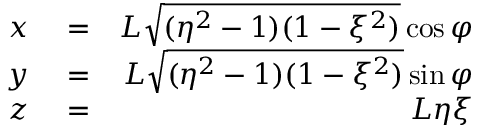Convert formula to latex. <formula><loc_0><loc_0><loc_500><loc_500>\begin{array} { r l r } { x } & = } & { L \sqrt { ( \eta ^ { 2 } - 1 ) ( 1 - \xi ^ { 2 } ) } \cos \varphi } \\ { y } & = } & { L \sqrt { ( \eta ^ { 2 } - 1 ) ( 1 - \xi ^ { 2 } ) } \sin \varphi } \\ { z } & = } & { L \eta \xi } \end{array}</formula> 